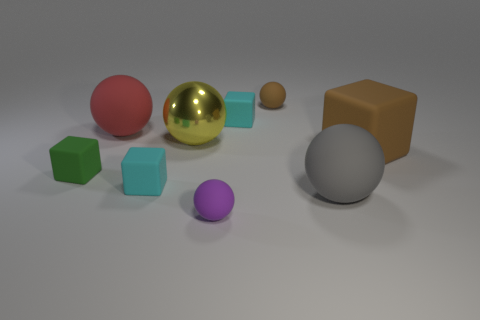Subtract all purple balls. How many balls are left? 4 Subtract all blue spheres. How many cyan cubes are left? 2 Subtract 1 spheres. How many spheres are left? 4 Subtract all cyan blocks. How many blocks are left? 2 Subtract all green spheres. Subtract all brown cylinders. How many spheres are left? 5 Add 1 spheres. How many spheres exist? 6 Subtract 0 red cubes. How many objects are left? 9 Subtract all spheres. How many objects are left? 4 Subtract all purple rubber spheres. Subtract all big blue objects. How many objects are left? 8 Add 1 large gray spheres. How many large gray spheres are left? 2 